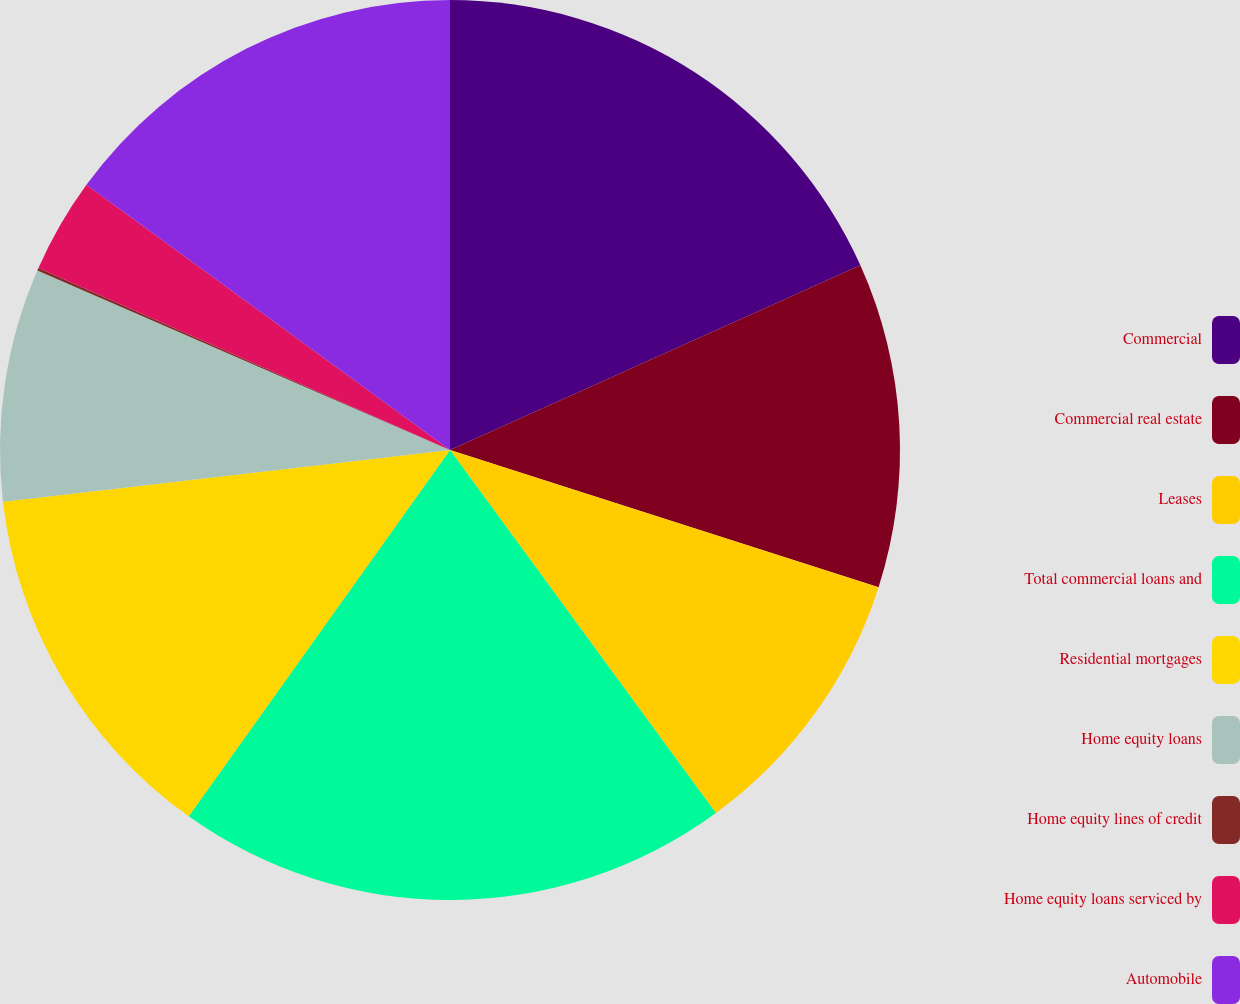<chart> <loc_0><loc_0><loc_500><loc_500><pie_chart><fcel>Commercial<fcel>Commercial real estate<fcel>Leases<fcel>Total commercial loans and<fcel>Residential mortgages<fcel>Home equity loans<fcel>Home equity lines of credit<fcel>Home equity loans serviced by<fcel>Automobile<nl><fcel>18.27%<fcel>11.66%<fcel>10.01%<fcel>19.92%<fcel>13.31%<fcel>8.36%<fcel>0.1%<fcel>3.4%<fcel>14.97%<nl></chart> 